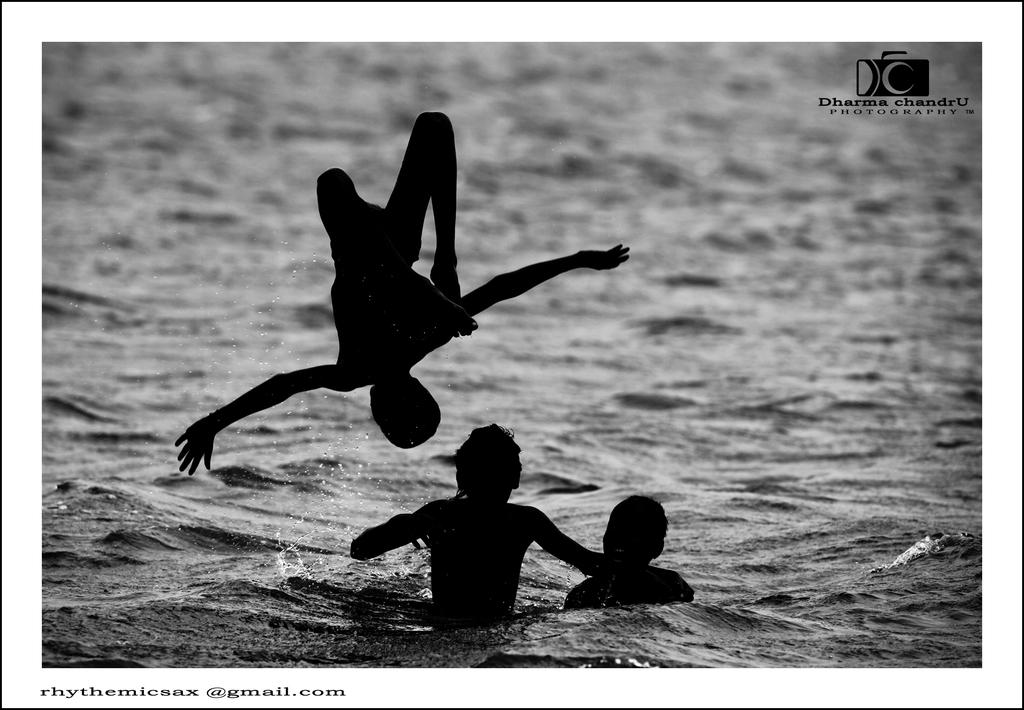What are the people in the image doing? There are two people in the water and one person in the air in the image. Can you describe the logo in the image? The logo has some text on it and is located in the bottom left corner of the image. Where is the logo in relation to the people in the image? The logo is in the top right corner of the image, separate from the people. What type of market is depicted in the image? There is no market present in the image. What operation is being performed by the person in the air? The image does not show any operation being performed by the person in the air; they are simply floating or flying. 